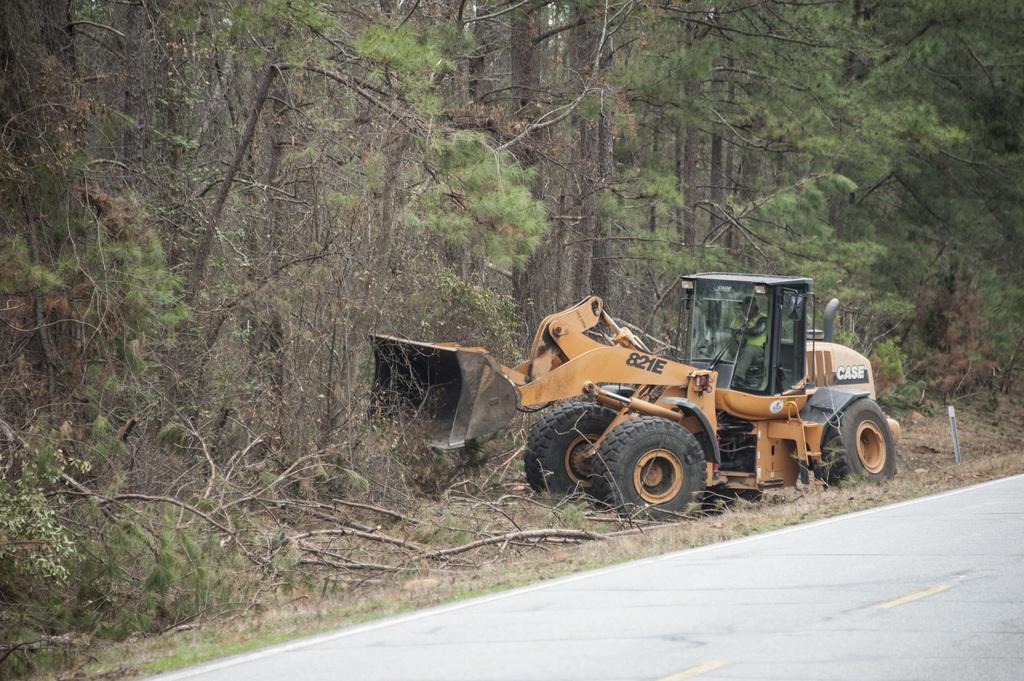Provide a one-sentence caption for the provided image. A bulldozer marked with 821E on its side pushes tree branches off the road. 